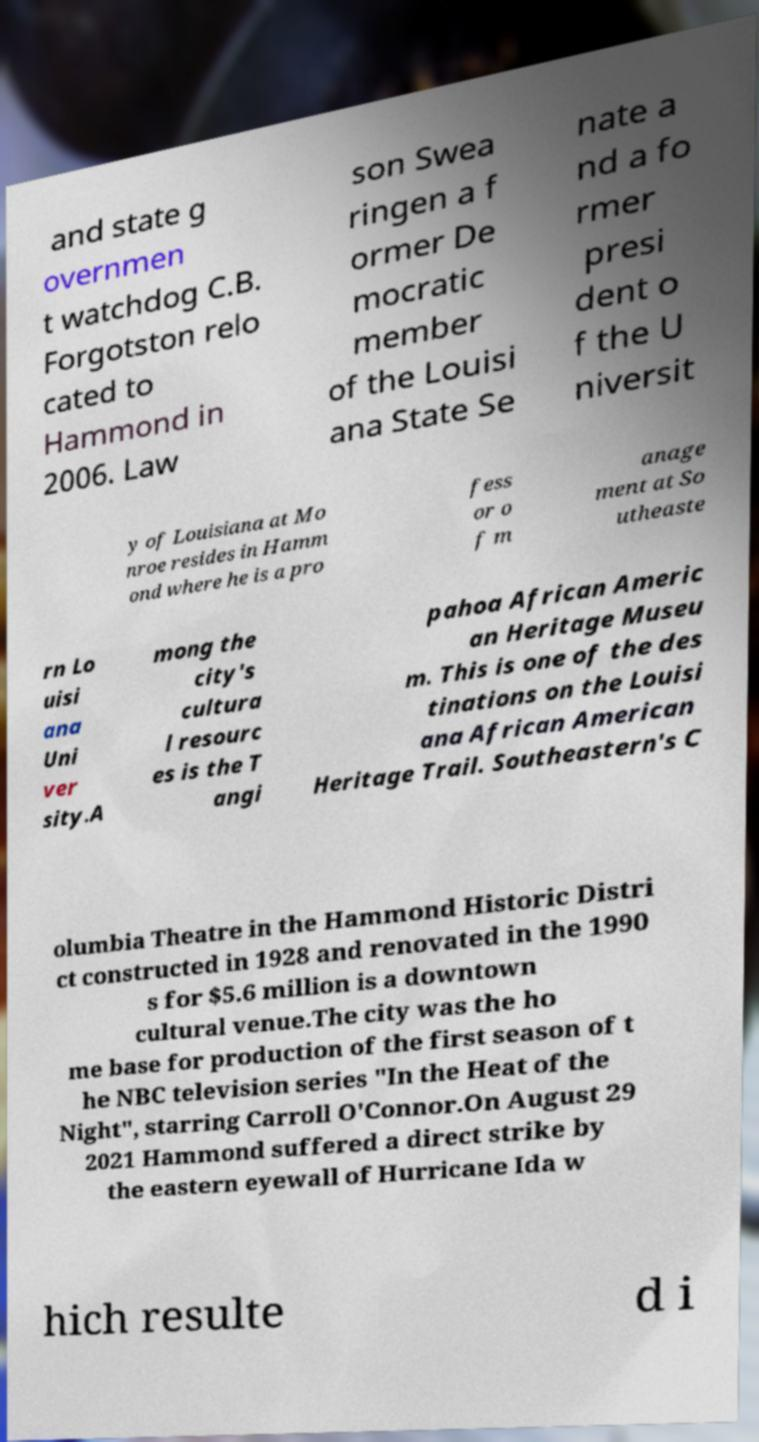I need the written content from this picture converted into text. Can you do that? and state g overnmen t watchdog C.B. Forgotston relo cated to Hammond in 2006. Law son Swea ringen a f ormer De mocratic member of the Louisi ana State Se nate a nd a fo rmer presi dent o f the U niversit y of Louisiana at Mo nroe resides in Hamm ond where he is a pro fess or o f m anage ment at So utheaste rn Lo uisi ana Uni ver sity.A mong the city's cultura l resourc es is the T angi pahoa African Americ an Heritage Museu m. This is one of the des tinations on the Louisi ana African American Heritage Trail. Southeastern's C olumbia Theatre in the Hammond Historic Distri ct constructed in 1928 and renovated in the 1990 s for $5.6 million is a downtown cultural venue.The city was the ho me base for production of the first season of t he NBC television series "In the Heat of the Night", starring Carroll O'Connor.On August 29 2021 Hammond suffered a direct strike by the eastern eyewall of Hurricane Ida w hich resulte d i 